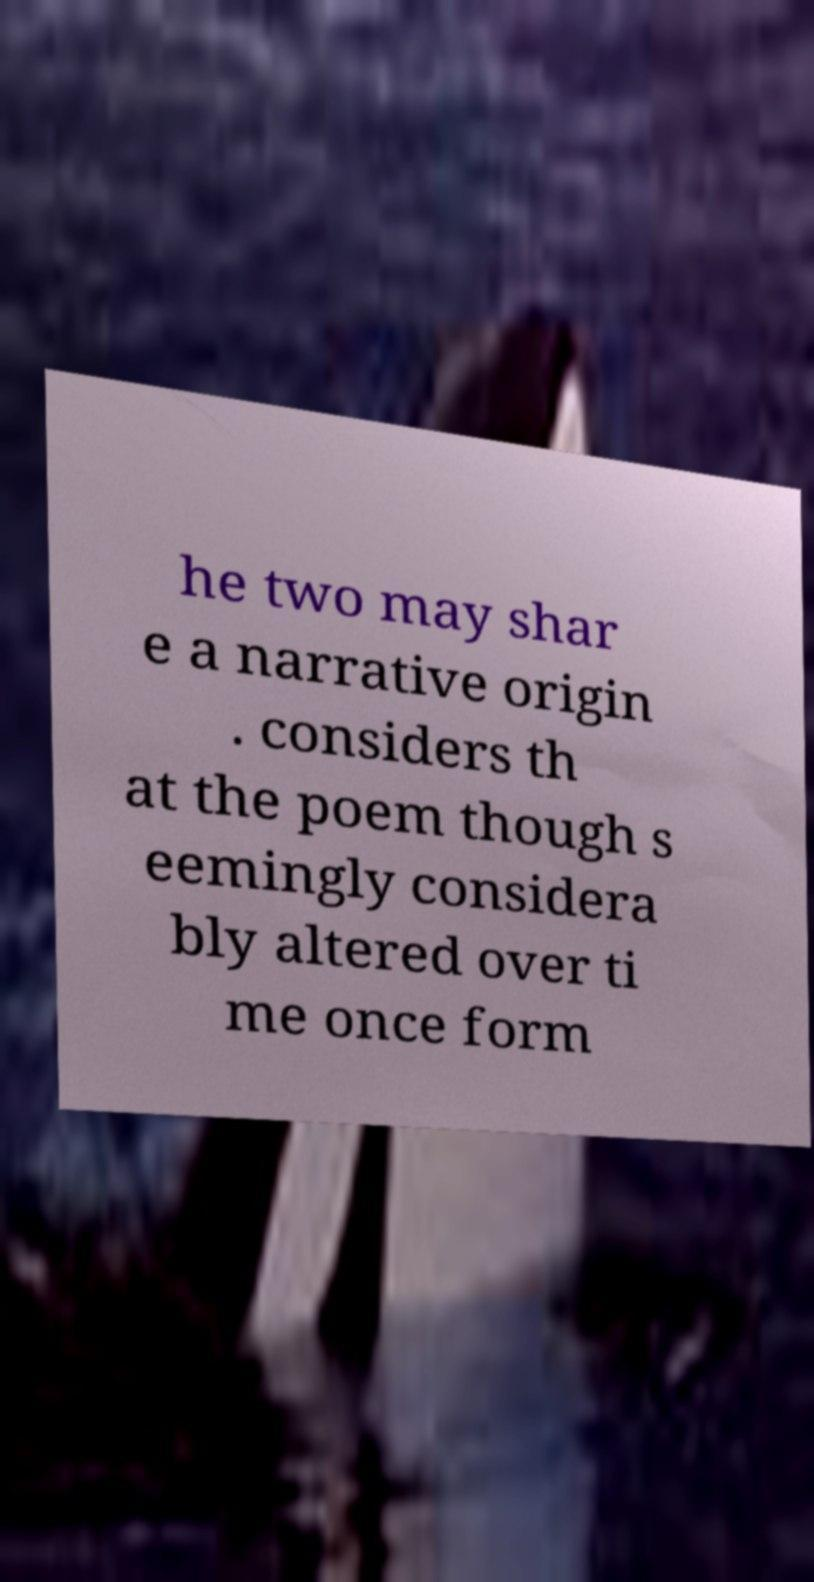I need the written content from this picture converted into text. Can you do that? he two may shar e a narrative origin . considers th at the poem though s eemingly considera bly altered over ti me once form 